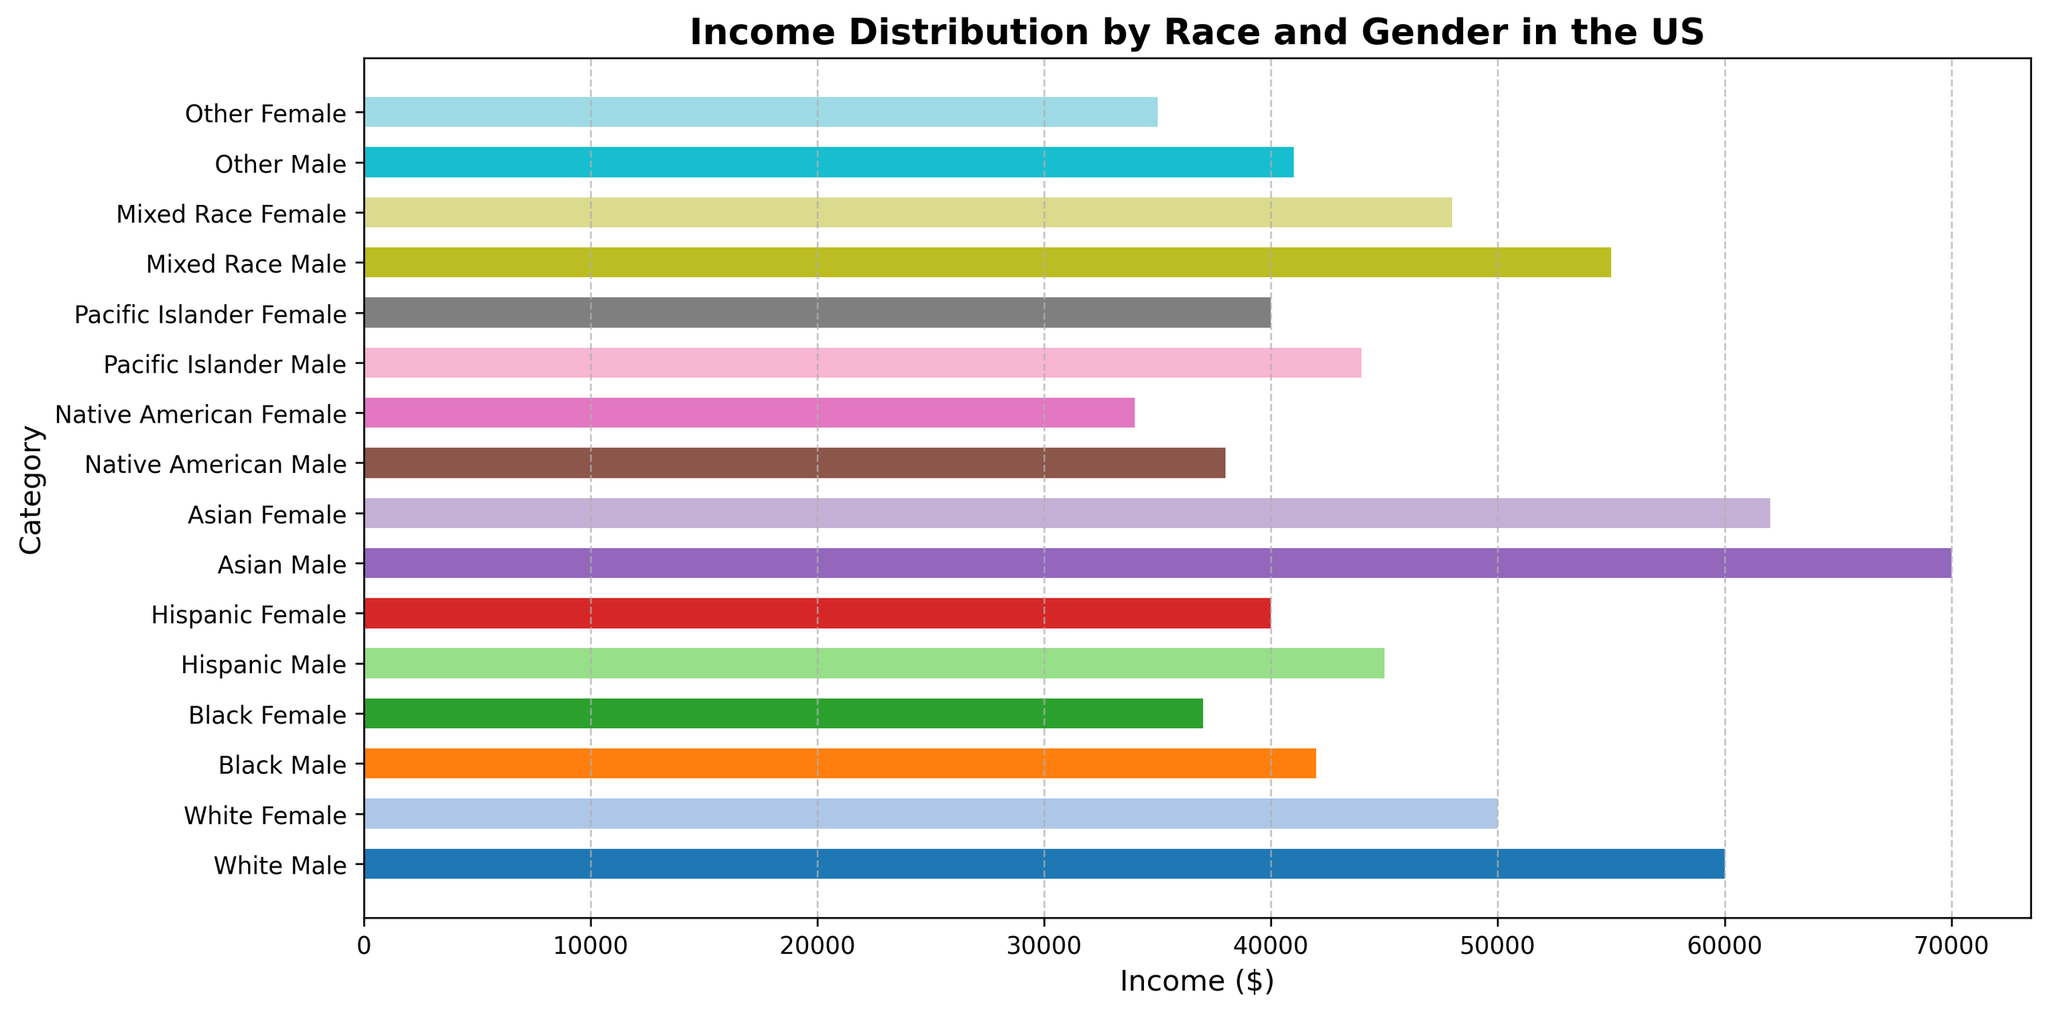Which group has the highest median income? By looking at the visual representation of the bars, we can see that the highest income bar belongs to the 'Asian Male' category.
Answer: Asian Male What is the income difference between Black Males and White Males? The income for Black Males is $42,000, and for White Males is $60,000. The difference can be calculated as $60,000 - $42,000.
Answer: $18,000 Which group has a lower income, Hispanic Females or Native American Males? By comparing the height of the bars for 'Hispanic Female' and 'Native American Male', we see that 'Native American Male' has an income of $38,000, which is lower than 'Hispanic Female' at $40,000.
Answer: Native American Males What's the average income of all Females listed in the chart? The incomes of all females are: $50,000 (White), $37,000 (Black), $40,000 (Hispanic), $62,000 (Asian), $34,000 (Native American), $40,000 (Pacific Islander), $48,000 (Mixed Race), and $35,000 (Other). The total sum is $346,000. The number of groups is 8, so the average income is calculated as $346,000 / 8.
Answer: $43,250 Which race has the smallest income gap between males and females within the same group? By comparing the differences in income between males and females of each race: White ($10,000), Black ($5,000), Hispanic ($5,000), Asian ($8,000), Native American ($4,000), Pacific Islander ($4,000), Mixed Race ($7,000), and Other ($6,000), we see that Native American and Pacific Islander both have the smallest gap, $4,000.
Answer: Native American and Pacific Islander What is the total income of all Mixed Race individuals? The income for Mixed Race Male is $55,000 and for Mixed Race Female is $48,000. The total income can be calculated by adding these two values: $55,000 + $48,000.
Answer: $103,000 Which gender overall appears to have a higher income within each racial category represented? By visually comparing the bars for each race, we can see that in each racial category except for 'Other', males have higher incomes than females.
Answer: Male How much more does the highest earning group make than the lowest earning group? The highest earning group is 'Asian Male' ($70,000) and the lowest earning group is 'Native American Female' ($34,000). The difference is calculated as $70,000 - $34,000.
Answer: $36,000 Which racial category's females earn more than 'Black Male'? By checking bars, 'White Female' ($50,000), 'Asian Female' ($62,000), and 'Mixed Race Female' ($48,000) all earn more than 'Black Male' ($42,000).
Answer: White Female, Asian Female, Mixed Race Female 